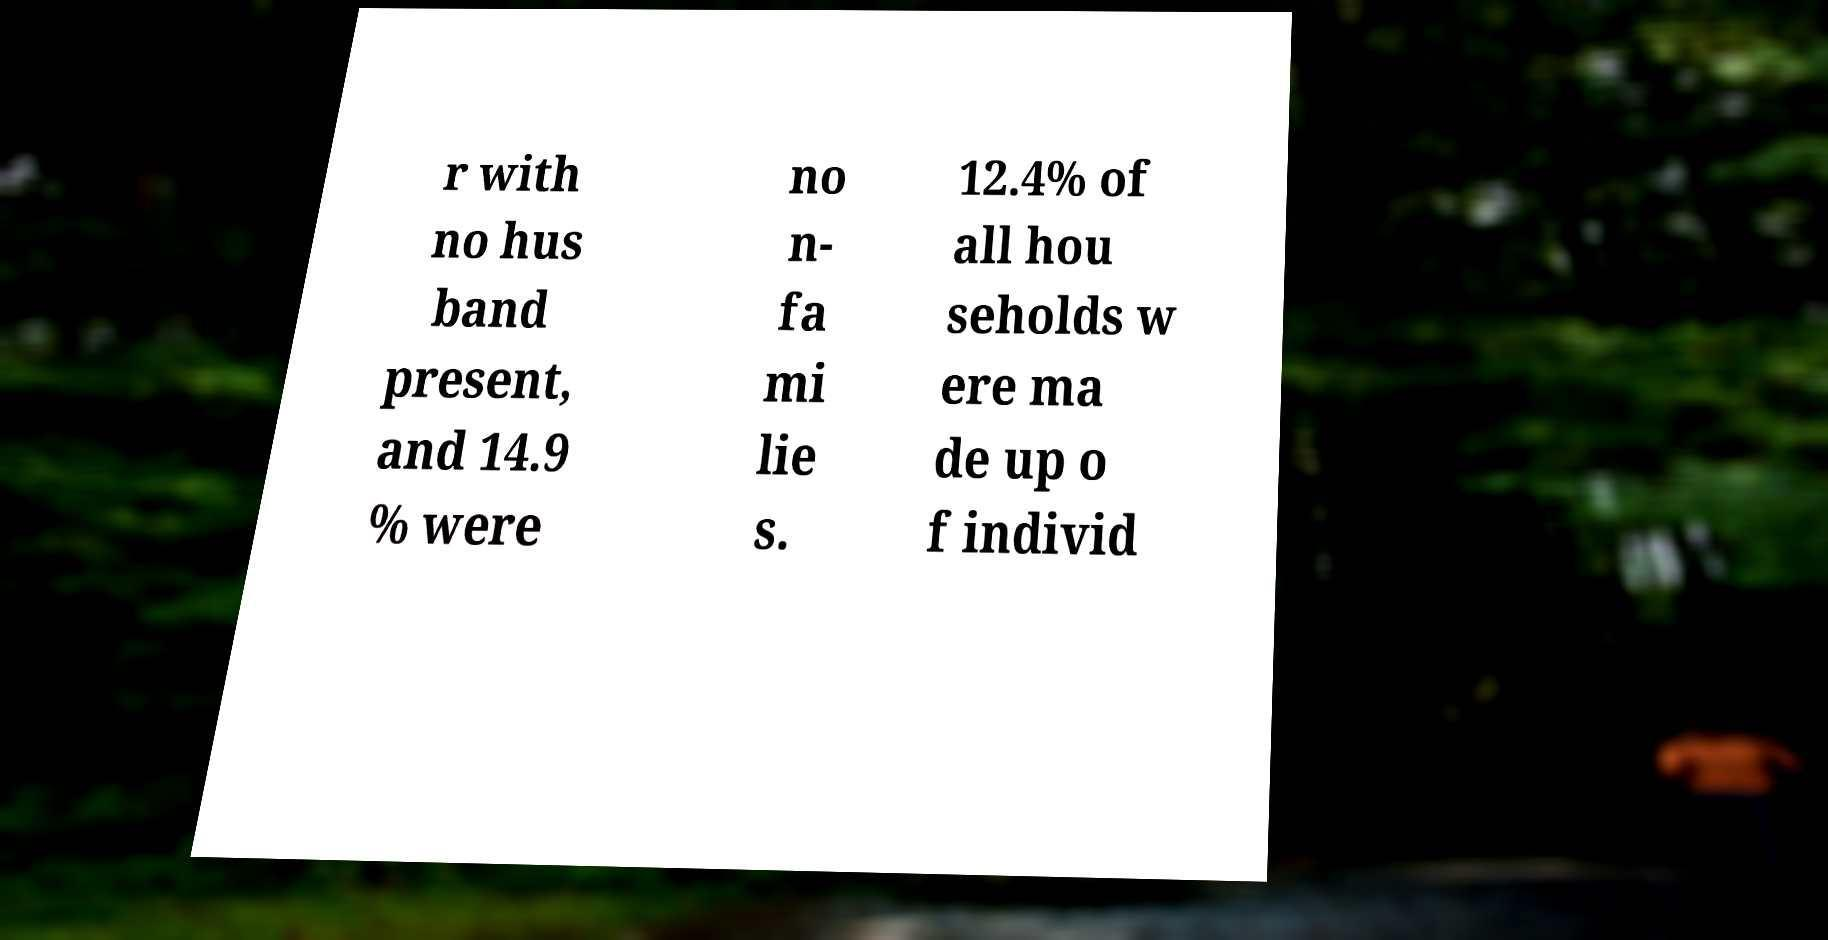What messages or text are displayed in this image? I need them in a readable, typed format. r with no hus band present, and 14.9 % were no n- fa mi lie s. 12.4% of all hou seholds w ere ma de up o f individ 